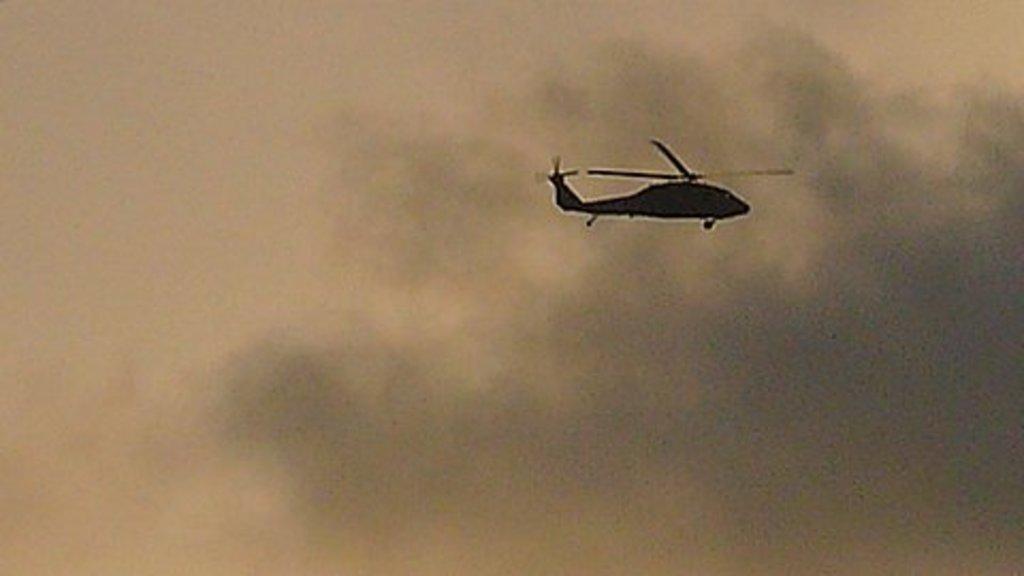Could you give a brief overview of what you see in this image? In this picture there is a helicopter in the sky. At the top there is sky and there are clouds. 